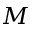<formula> <loc_0><loc_0><loc_500><loc_500>M</formula> 